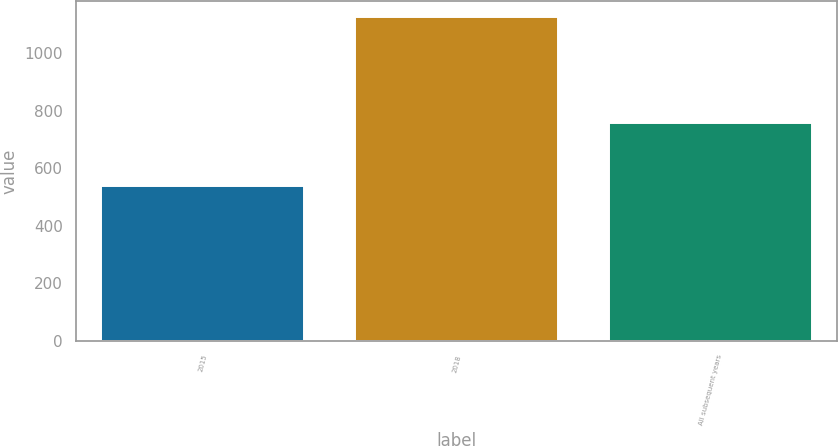Convert chart. <chart><loc_0><loc_0><loc_500><loc_500><bar_chart><fcel>2015<fcel>2018<fcel>All subsequent years<nl><fcel>540<fcel>1126<fcel>759<nl></chart> 